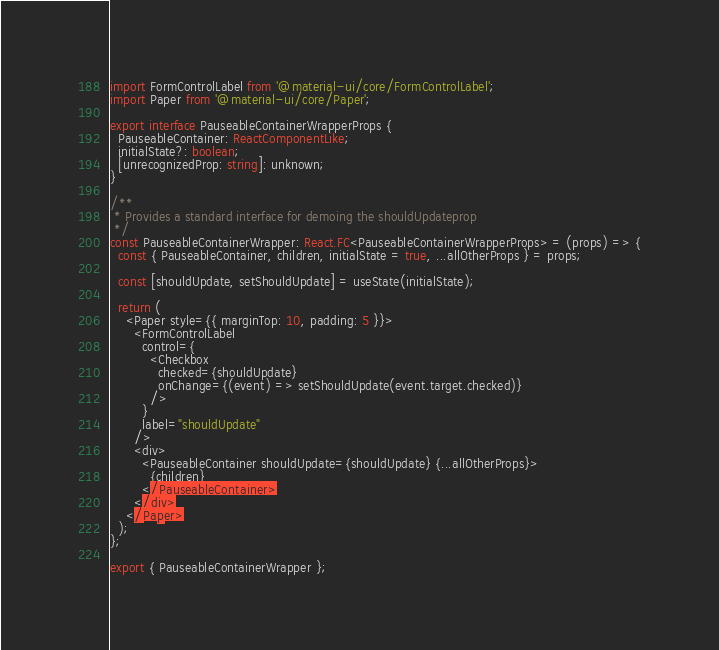Convert code to text. <code><loc_0><loc_0><loc_500><loc_500><_TypeScript_>import FormControlLabel from '@material-ui/core/FormControlLabel';
import Paper from '@material-ui/core/Paper';

export interface PauseableContainerWrapperProps {
  PauseableContainer: ReactComponentLike;
  initialState?: boolean;
  [unrecognizedProp: string]: unknown;
}

/**
 * Provides a standard interface for demoing the shouldUpdateprop
 */
const PauseableContainerWrapper: React.FC<PauseableContainerWrapperProps> = (props) => {
  const { PauseableContainer, children, initialState = true, ...allOtherProps } = props;

  const [shouldUpdate, setShouldUpdate] = useState(initialState);

  return (
    <Paper style={{ marginTop: 10, padding: 5 }}>
      <FormControlLabel
        control={
          <Checkbox
            checked={shouldUpdate}
            onChange={(event) => setShouldUpdate(event.target.checked)}
          />
        }
        label="shouldUpdate"
      />
      <div>
        <PauseableContainer shouldUpdate={shouldUpdate} {...allOtherProps}>
          {children}
        </PauseableContainer>
      </div>
    </Paper>
  );
};

export { PauseableContainerWrapper };
</code> 